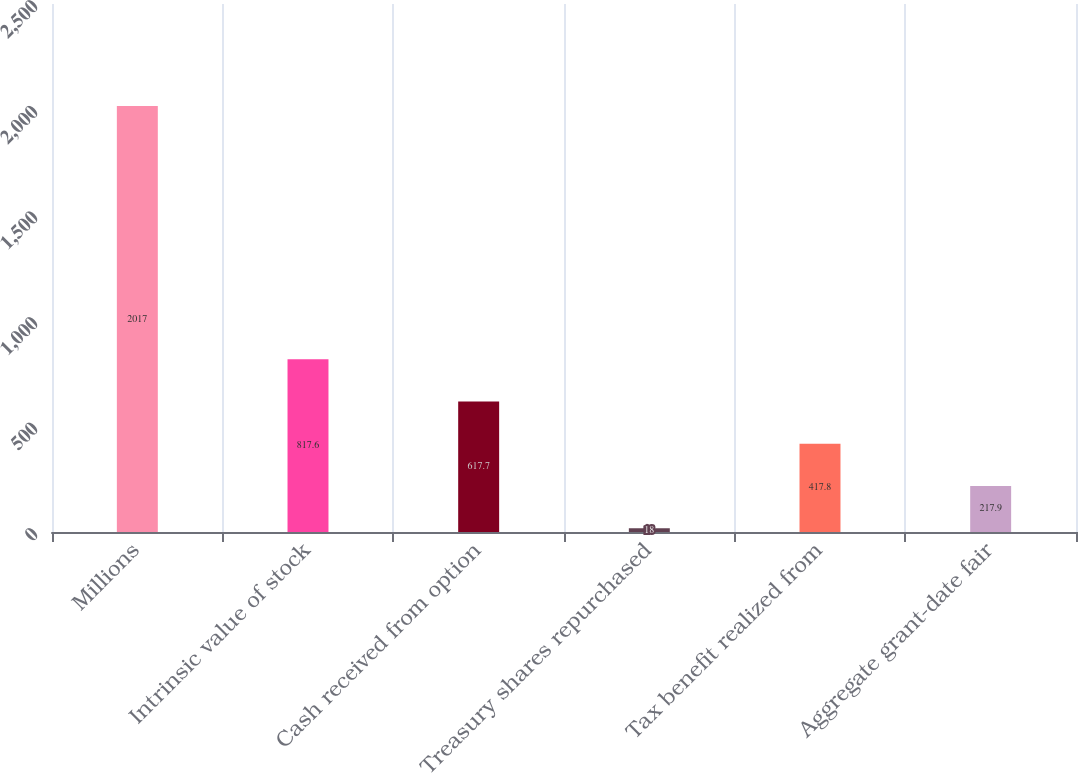Convert chart. <chart><loc_0><loc_0><loc_500><loc_500><bar_chart><fcel>Millions<fcel>Intrinsic value of stock<fcel>Cash received from option<fcel>Treasury shares repurchased<fcel>Tax benefit realized from<fcel>Aggregate grant-date fair<nl><fcel>2017<fcel>817.6<fcel>617.7<fcel>18<fcel>417.8<fcel>217.9<nl></chart> 